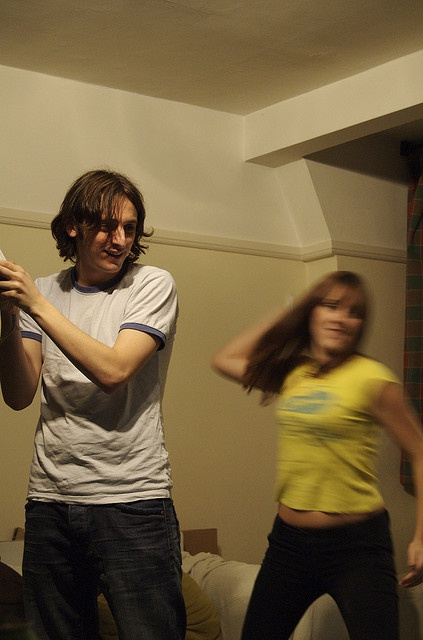Describe the objects in this image and their specific colors. I can see people in olive, black, tan, and maroon tones, people in olive, black, and maroon tones, couch in olive and black tones, and remote in olive and tan tones in this image. 